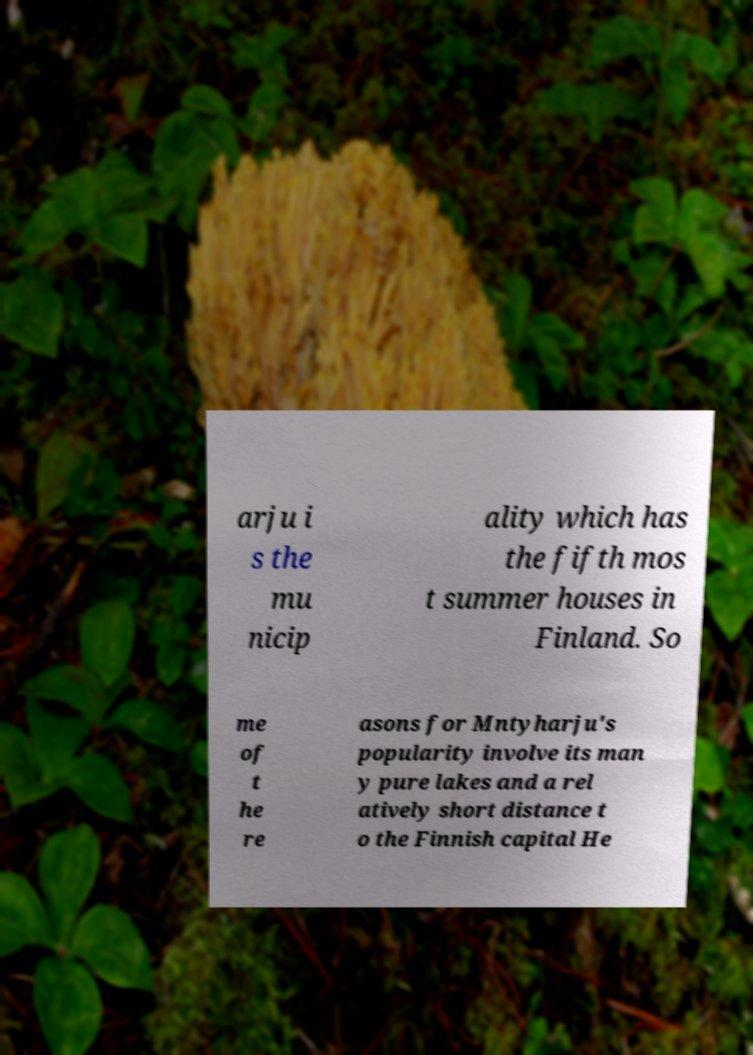Please read and relay the text visible in this image. What does it say? arju i s the mu nicip ality which has the fifth mos t summer houses in Finland. So me of t he re asons for Mntyharju's popularity involve its man y pure lakes and a rel atively short distance t o the Finnish capital He 